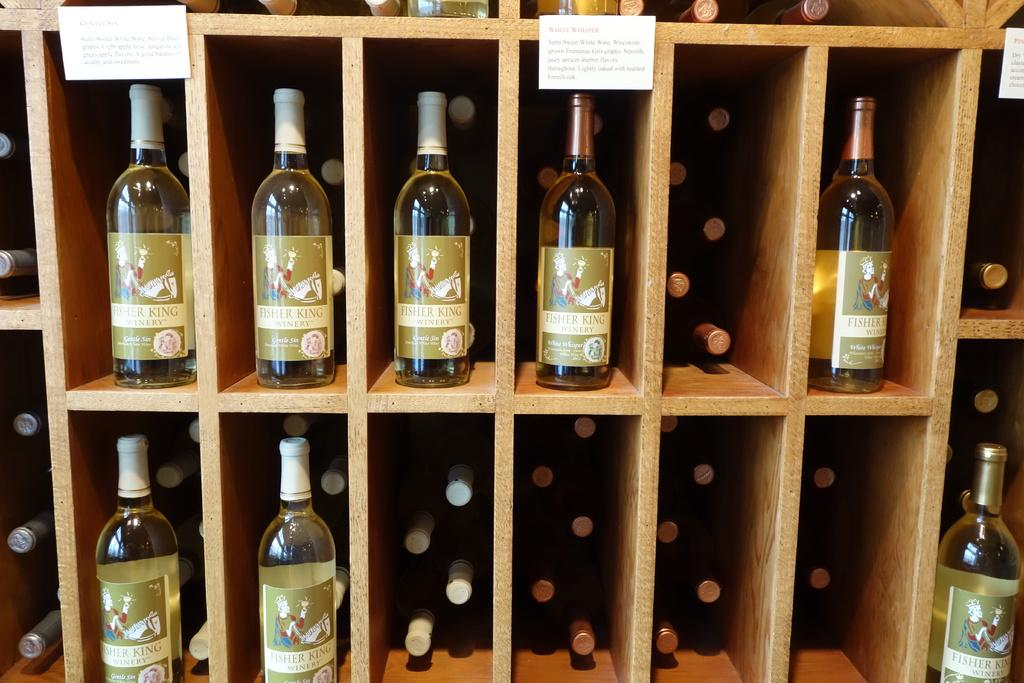What objects are in the image that are typically used for holding liquids? There are bottles in the image. How are the bottles arranged in the image? The bottles are in racks. What type of stationery items can be seen in the image? There are 3 papers in the image. What type of fuel is being stored in the bottles in the image? The bottles in the image are not storing any fuel; they are likely holding liquids such as water or beverages. 